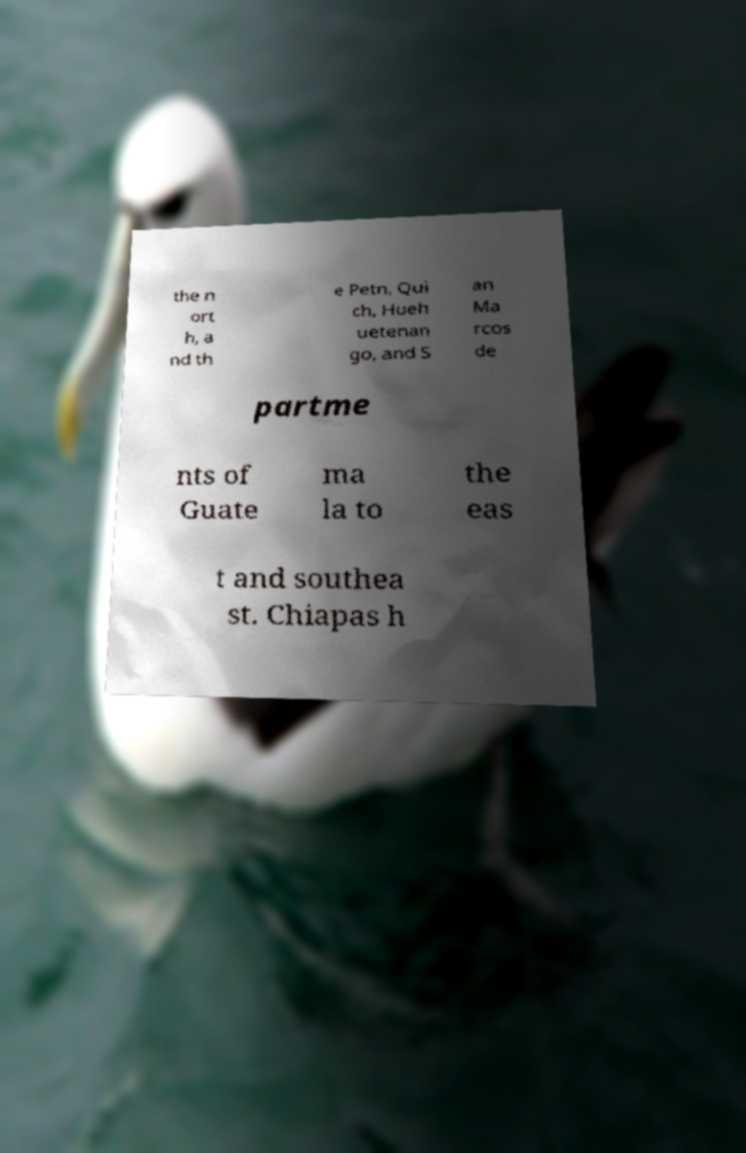Could you extract and type out the text from this image? the n ort h, a nd th e Petn, Qui ch, Hueh uetenan go, and S an Ma rcos de partme nts of Guate ma la to the eas t and southea st. Chiapas h 